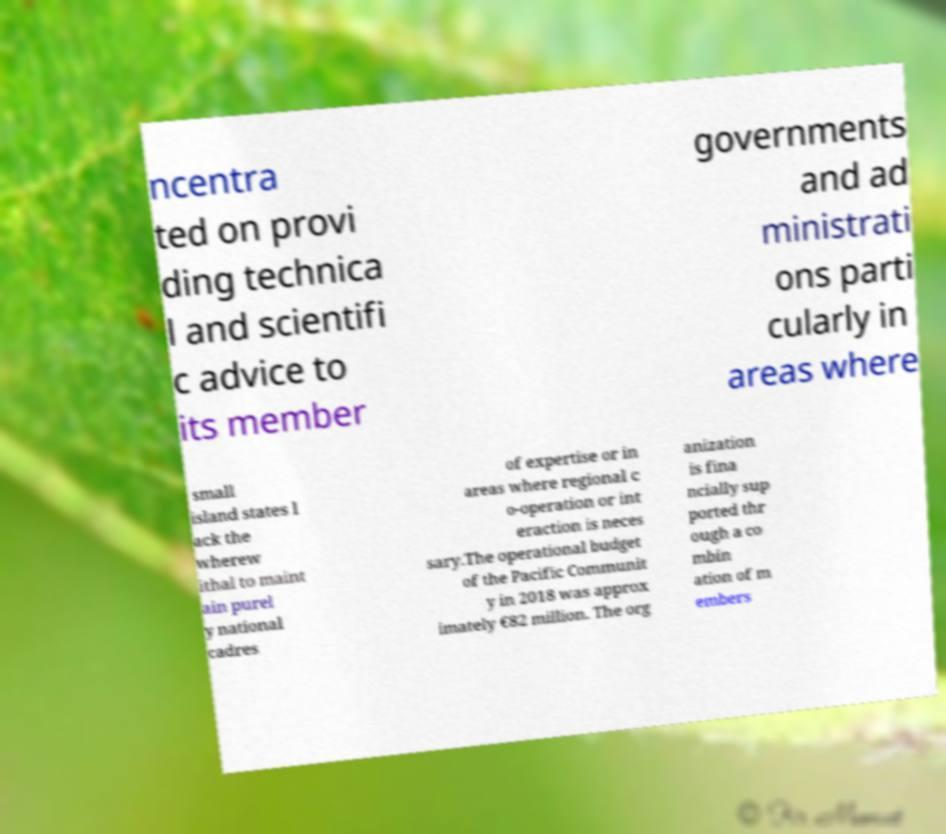There's text embedded in this image that I need extracted. Can you transcribe it verbatim? ncentra ted on provi ding technica l and scientifi c advice to its member governments and ad ministrati ons parti cularly in areas where small island states l ack the wherew ithal to maint ain purel y national cadres of expertise or in areas where regional c o-operation or int eraction is neces sary.The operational budget of the Pacific Communit y in 2018 was approx imately €82 million. The org anization is fina ncially sup ported thr ough a co mbin ation of m embers 